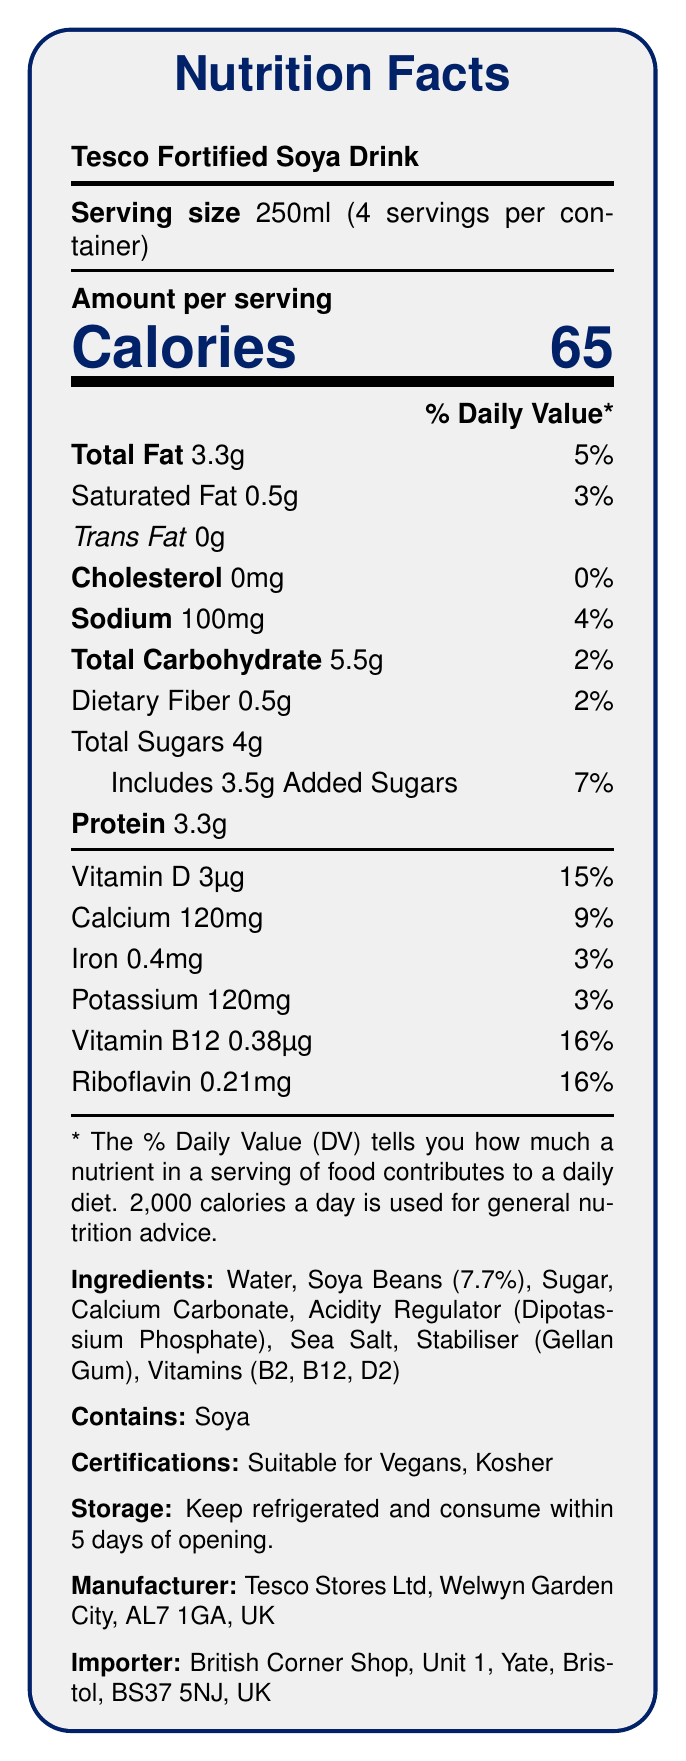what is the serving size? The document lists "Serving size 250ml" under the product title.
Answer: 250ml how many calories are in one serving? The label states "Calories 65" in the Amount per serving section.
Answer: 65 how much total fat is in one serving? The label specifies "Total Fat 3.3g".
Answer: 3.3g what is the percentage of daily value for vitamin D in a serving? The document lists "Vitamin D 3µg 15%" in the percentage daily value section.
Answer: 15% name two certifications this product has. The document lists "Certifications: Suitable for Vegans, Kosher".
Answer: Suitable for Vegans, Kosher how long should the product be consumed after opening? The storage instructions mention "consume within 5 days of opening".
Answer: 5 days what ingredient comes second in the list? The ingredients list Water first and Soya Beans (7.7%) second.
Answer: Soya Beans (7.7%) which vitamin has the highest percent daily value in this product? A. Vitamin D B. Calcium C. Vitamin B12 D. Riboflavin Riboflavin is listed with a 16% daily value, which is the highest compared to other vitamins listed.
Answer: D. Riboflavin what is the amount of added sugars in one serving? A. 2g B. 3.5g C. 4g D. 5g The label shows "Includes 3.5g Added Sugars".
Answer: B. 3.5g does this product contain any cholesterol? The document specifies "Cholesterol 0mg".
Answer: No summarize the document in a sentence. The document includes a detailed breakdown of the nutritional content, ingredients, and instructions relevant to Tesco Fortified Soya Drink.
Answer: This document provides the nutrition facts and additional information about Tesco Fortified Soya Drink, including serving size, calorie content, nutrient amounts, ingredients, allergen information, certifications, storage instructions, and manufacturer details. what is the percent daily value for total carbohydrates? The document lists "Total Carbohydrate 5.5g 2%".
Answer: 2% how many servings are in the container? The document states that there are 4 servings per container.
Answer: 4 how much sodium is in one serving? The label specifies "Sodium 100mg".
Answer: 100mg what is the manufacturer's address? The manufacturer's information is given as Tesco Stores Ltd, Welwyn Garden City, AL7 1GA, UK on the document.
Answer: Tesco Stores Ltd, Welwyn Garden City, AL7 1GA, UK can I find out if the product is non-GMO from the document? The document does not provide any information about whether the product is non-GMO.
Answer: Not enough information 